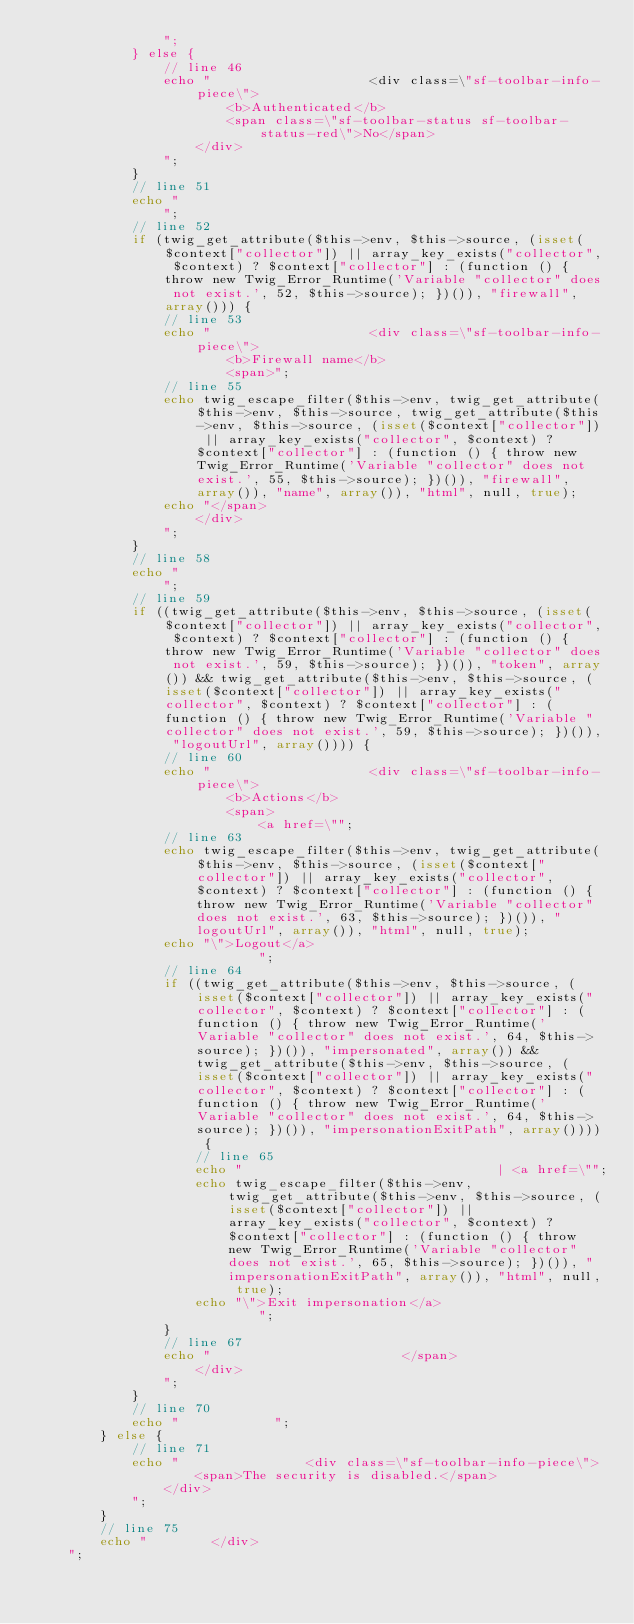Convert code to text. <code><loc_0><loc_0><loc_500><loc_500><_PHP_>                ";
            } else {
                // line 46
                echo "                    <div class=\"sf-toolbar-info-piece\">
                        <b>Authenticated</b>
                        <span class=\"sf-toolbar-status sf-toolbar-status-red\">No</span>
                    </div>
                ";
            }
            // line 51
            echo "
                ";
            // line 52
            if (twig_get_attribute($this->env, $this->source, (isset($context["collector"]) || array_key_exists("collector", $context) ? $context["collector"] : (function () { throw new Twig_Error_Runtime('Variable "collector" does not exist.', 52, $this->source); })()), "firewall", array())) {
                // line 53
                echo "                    <div class=\"sf-toolbar-info-piece\">
                        <b>Firewall name</b>
                        <span>";
                // line 55
                echo twig_escape_filter($this->env, twig_get_attribute($this->env, $this->source, twig_get_attribute($this->env, $this->source, (isset($context["collector"]) || array_key_exists("collector", $context) ? $context["collector"] : (function () { throw new Twig_Error_Runtime('Variable "collector" does not exist.', 55, $this->source); })()), "firewall", array()), "name", array()), "html", null, true);
                echo "</span>
                    </div>
                ";
            }
            // line 58
            echo "
                ";
            // line 59
            if ((twig_get_attribute($this->env, $this->source, (isset($context["collector"]) || array_key_exists("collector", $context) ? $context["collector"] : (function () { throw new Twig_Error_Runtime('Variable "collector" does not exist.', 59, $this->source); })()), "token", array()) && twig_get_attribute($this->env, $this->source, (isset($context["collector"]) || array_key_exists("collector", $context) ? $context["collector"] : (function () { throw new Twig_Error_Runtime('Variable "collector" does not exist.', 59, $this->source); })()), "logoutUrl", array()))) {
                // line 60
                echo "                    <div class=\"sf-toolbar-info-piece\">
                        <b>Actions</b>
                        <span>
                            <a href=\"";
                // line 63
                echo twig_escape_filter($this->env, twig_get_attribute($this->env, $this->source, (isset($context["collector"]) || array_key_exists("collector", $context) ? $context["collector"] : (function () { throw new Twig_Error_Runtime('Variable "collector" does not exist.', 63, $this->source); })()), "logoutUrl", array()), "html", null, true);
                echo "\">Logout</a>
                            ";
                // line 64
                if ((twig_get_attribute($this->env, $this->source, (isset($context["collector"]) || array_key_exists("collector", $context) ? $context["collector"] : (function () { throw new Twig_Error_Runtime('Variable "collector" does not exist.', 64, $this->source); })()), "impersonated", array()) && twig_get_attribute($this->env, $this->source, (isset($context["collector"]) || array_key_exists("collector", $context) ? $context["collector"] : (function () { throw new Twig_Error_Runtime('Variable "collector" does not exist.', 64, $this->source); })()), "impersonationExitPath", array()))) {
                    // line 65
                    echo "                                | <a href=\"";
                    echo twig_escape_filter($this->env, twig_get_attribute($this->env, $this->source, (isset($context["collector"]) || array_key_exists("collector", $context) ? $context["collector"] : (function () { throw new Twig_Error_Runtime('Variable "collector" does not exist.', 65, $this->source); })()), "impersonationExitPath", array()), "html", null, true);
                    echo "\">Exit impersonation</a>
                            ";
                }
                // line 67
                echo "                        </span>
                    </div>
                ";
            }
            // line 70
            echo "            ";
        } else {
            // line 71
            echo "                <div class=\"sf-toolbar-info-piece\">
                    <span>The security is disabled.</span>
                </div>
            ";
        }
        // line 75
        echo "        </div>
    ";</code> 